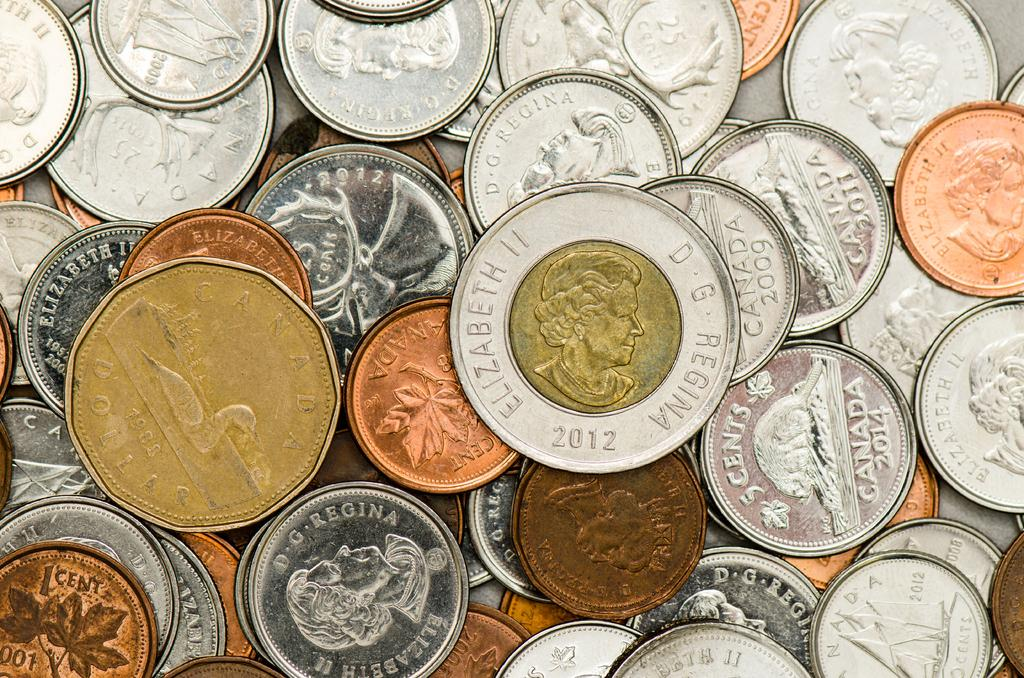<image>
Share a concise interpretation of the image provided. Many different coins, several of which have either Elizabeth II or Canada on them. 